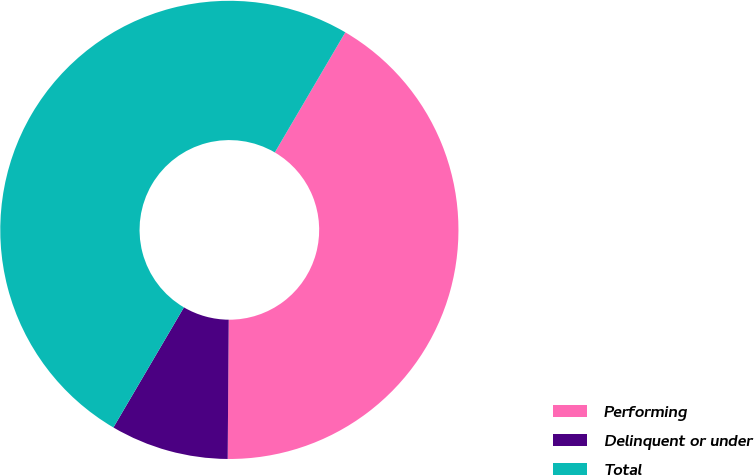Convert chart to OTSL. <chart><loc_0><loc_0><loc_500><loc_500><pie_chart><fcel>Performing<fcel>Delinquent or under<fcel>Total<nl><fcel>41.67%<fcel>8.33%<fcel>50.0%<nl></chart> 